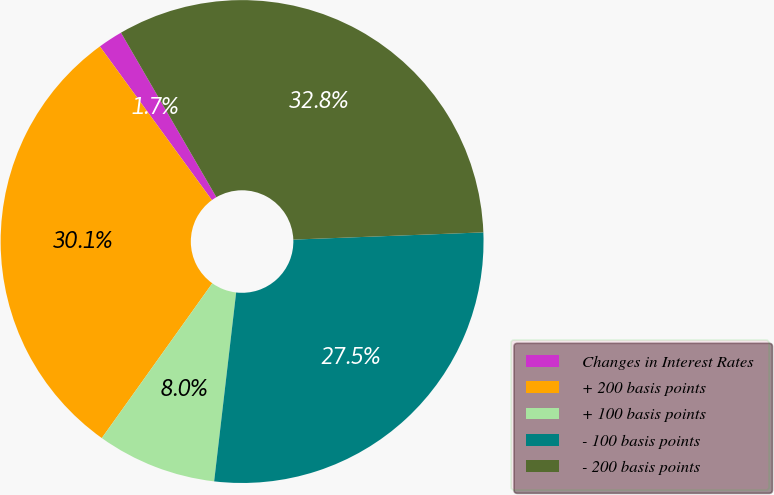<chart> <loc_0><loc_0><loc_500><loc_500><pie_chart><fcel>Changes in Interest Rates<fcel>+ 200 basis points<fcel>+ 100 basis points<fcel>- 100 basis points<fcel>- 200 basis points<nl><fcel>1.66%<fcel>30.11%<fcel>8.02%<fcel>27.45%<fcel>32.76%<nl></chart> 